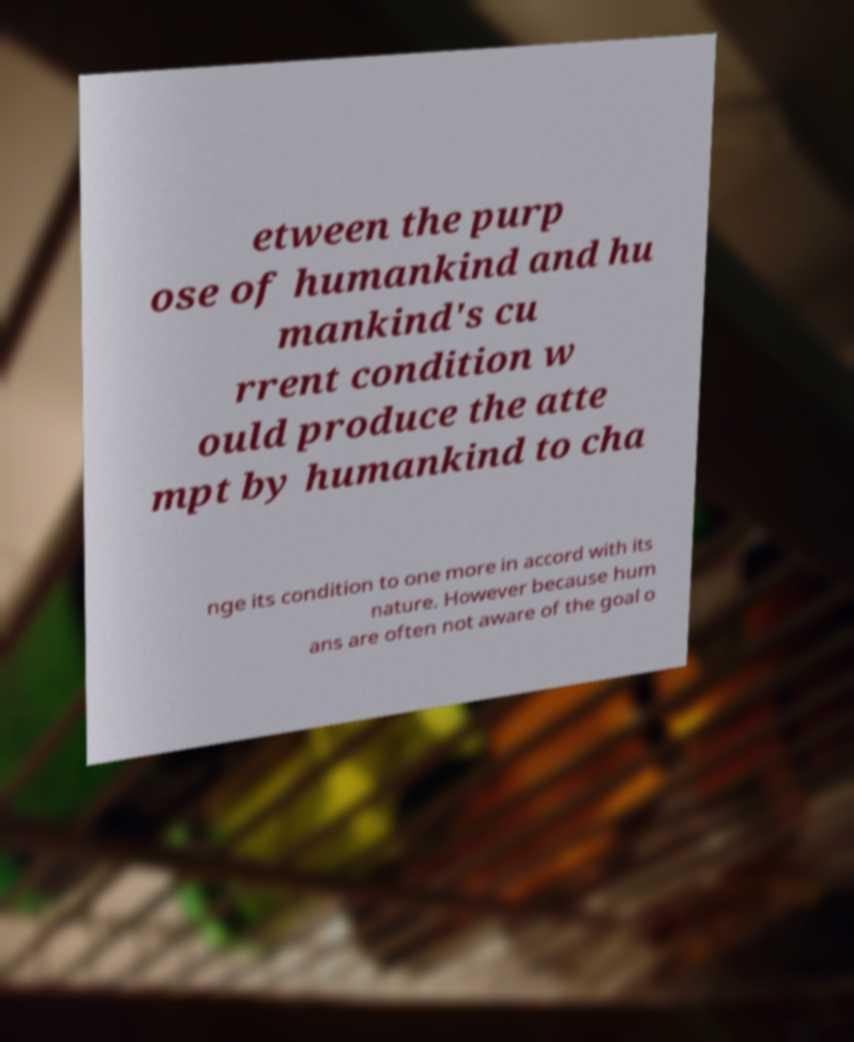I need the written content from this picture converted into text. Can you do that? etween the purp ose of humankind and hu mankind's cu rrent condition w ould produce the atte mpt by humankind to cha nge its condition to one more in accord with its nature. However because hum ans are often not aware of the goal o 